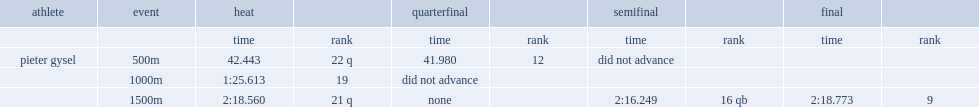In the 2010 winter olympics, who finished 21st with a time of 2:18.560? Pieter gysel. 